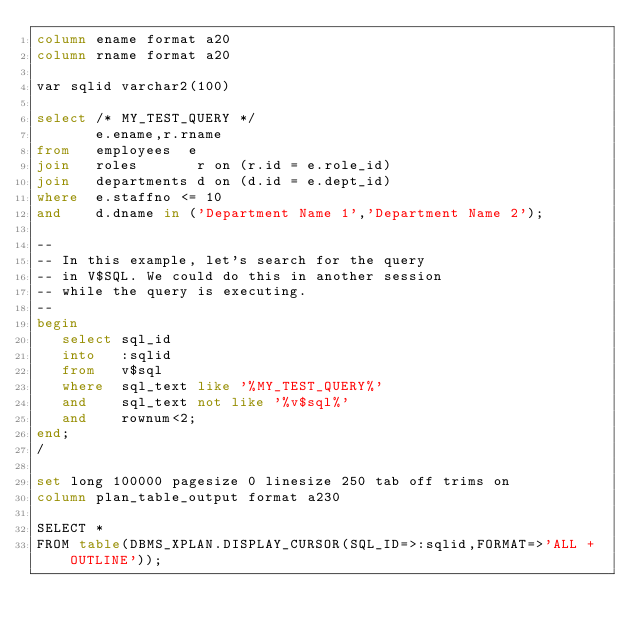Convert code to text. <code><loc_0><loc_0><loc_500><loc_500><_SQL_>column ename format a20
column rname format a20

var sqlid varchar2(100)

select /* MY_TEST_QUERY */
       e.ename,r.rname
from   employees  e
join   roles       r on (r.id = e.role_id)
join   departments d on (d.id = e.dept_id)
where  e.staffno <= 10
and    d.dname in ('Department Name 1','Department Name 2');

--
-- In this example, let's search for the query
-- in V$SQL. We could do this in another session
-- while the query is executing.
--
begin
   select sql_id
   into   :sqlid
   from   v$sql 
   where  sql_text like '%MY_TEST_QUERY%'
   and    sql_text not like '%v$sql%'
   and    rownum<2;
end;
/

set long 100000 pagesize 0 linesize 250 tab off trims on
column plan_table_output format a230

SELECT *
FROM table(DBMS_XPLAN.DISPLAY_CURSOR(SQL_ID=>:sqlid,FORMAT=>'ALL +OUTLINE'));

</code> 